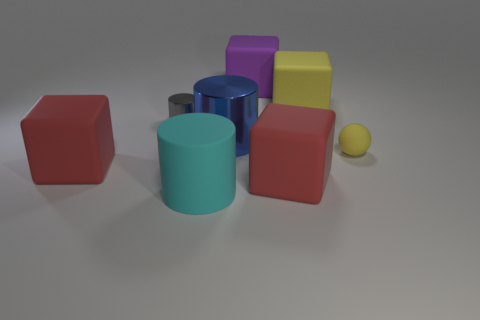Add 1 purple matte objects. How many objects exist? 9 Subtract all yellow cubes. How many cubes are left? 3 Subtract all blue cylinders. How many cylinders are left? 2 Subtract 1 cubes. How many cubes are left? 3 Subtract all gray cylinders. How many gray blocks are left? 0 Subtract all balls. How many objects are left? 7 Subtract all cyan spheres. Subtract all cyan cylinders. How many spheres are left? 1 Subtract all tiny gray shiny cylinders. Subtract all tiny metallic cylinders. How many objects are left? 6 Add 6 large purple matte things. How many large purple matte things are left? 7 Add 3 large rubber cubes. How many large rubber cubes exist? 7 